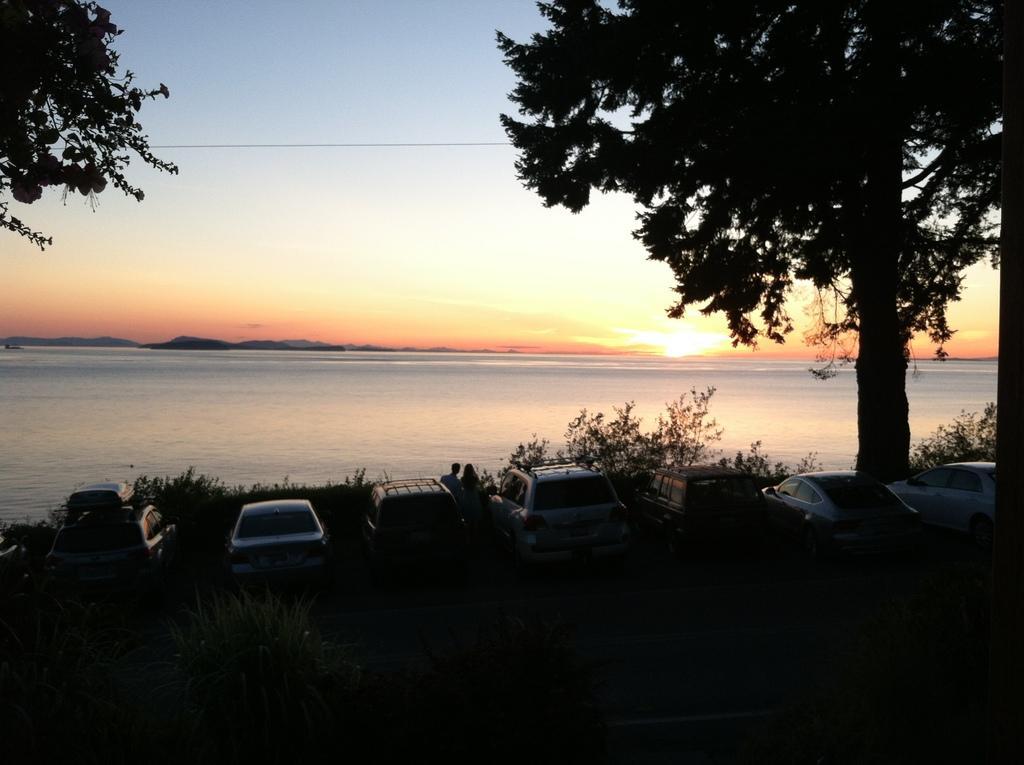Could you give a brief overview of what you see in this image? In this image I can see number of cars and both side of it I can see few trees and few people. In the background I can see water and the sky. I can also see this image is little bit in dark. 